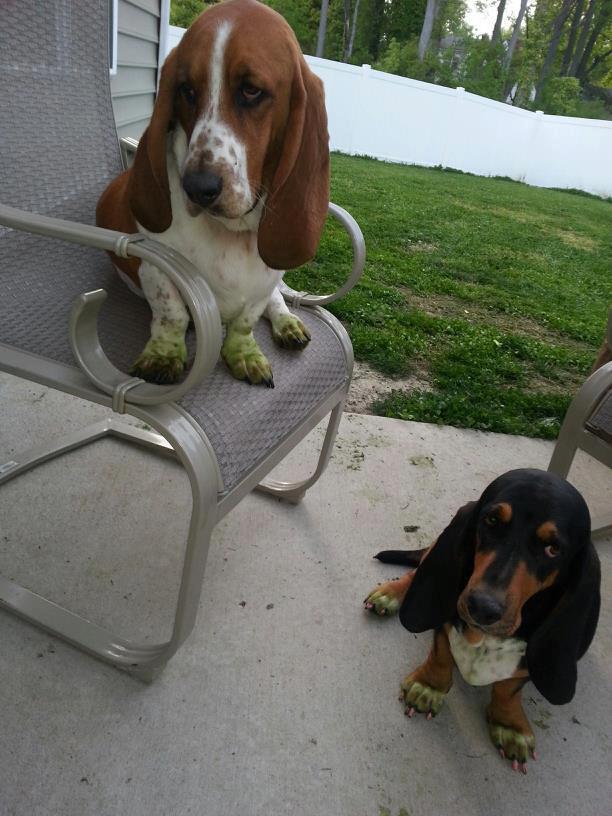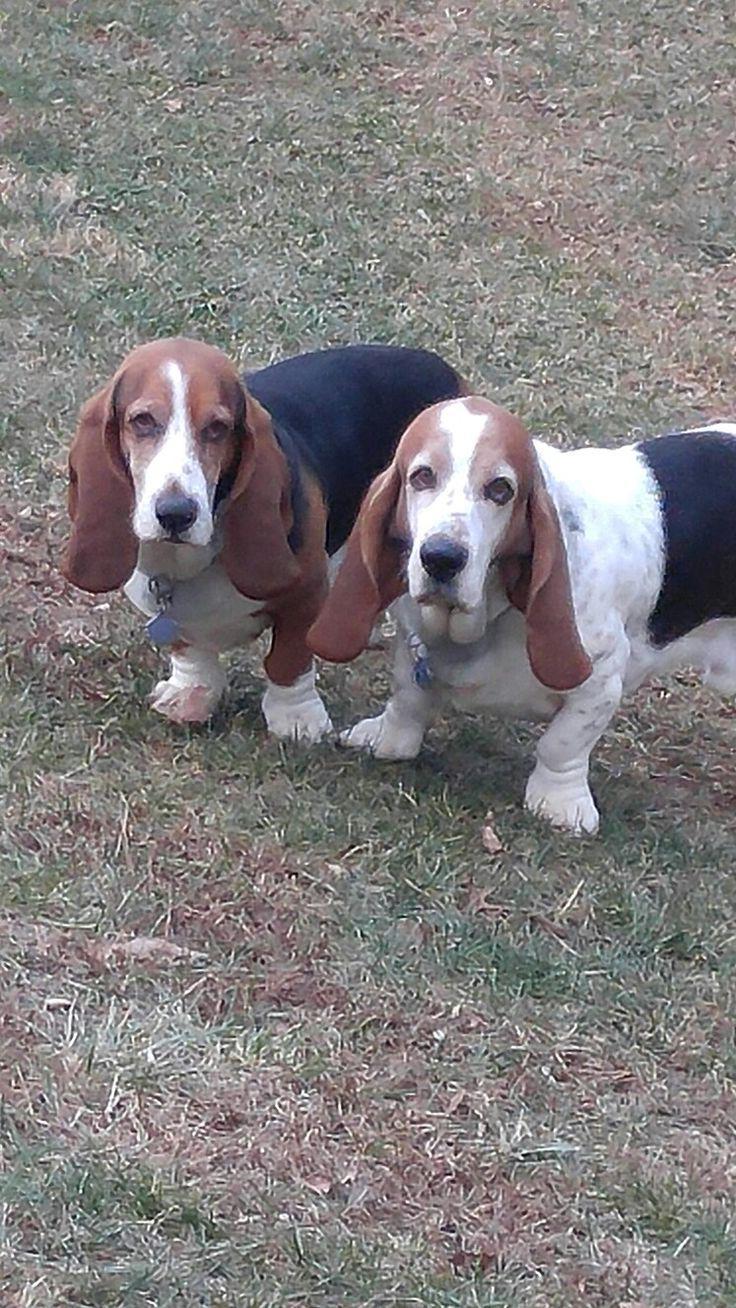The first image is the image on the left, the second image is the image on the right. Assess this claim about the two images: "At least one dog is laying down.". Correct or not? Answer yes or no. No. The first image is the image on the left, the second image is the image on the right. Analyze the images presented: Is the assertion "In one of the images, there are at least four dogs." valid? Answer yes or no. No. 